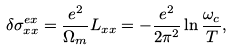<formula> <loc_0><loc_0><loc_500><loc_500>\delta \sigma ^ { e x } _ { x x } = \frac { e ^ { 2 } } { \Omega _ { m } } L _ { x x } = - \frac { e ^ { 2 } } { 2 \pi ^ { 2 } } \ln \frac { \omega _ { c } } { T } ,</formula> 